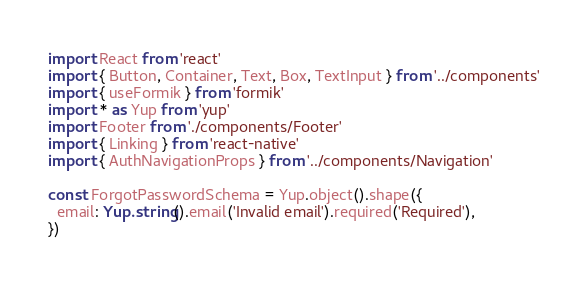<code> <loc_0><loc_0><loc_500><loc_500><_TypeScript_>import React from 'react'
import { Button, Container, Text, Box, TextInput } from '../components'
import { useFormik } from 'formik'
import * as Yup from 'yup'
import Footer from './components/Footer'
import { Linking } from 'react-native'
import { AuthNavigationProps } from '../components/Navigation'

const ForgotPasswordSchema = Yup.object().shape({
  email: Yup.string().email('Invalid email').required('Required'),
})
</code> 